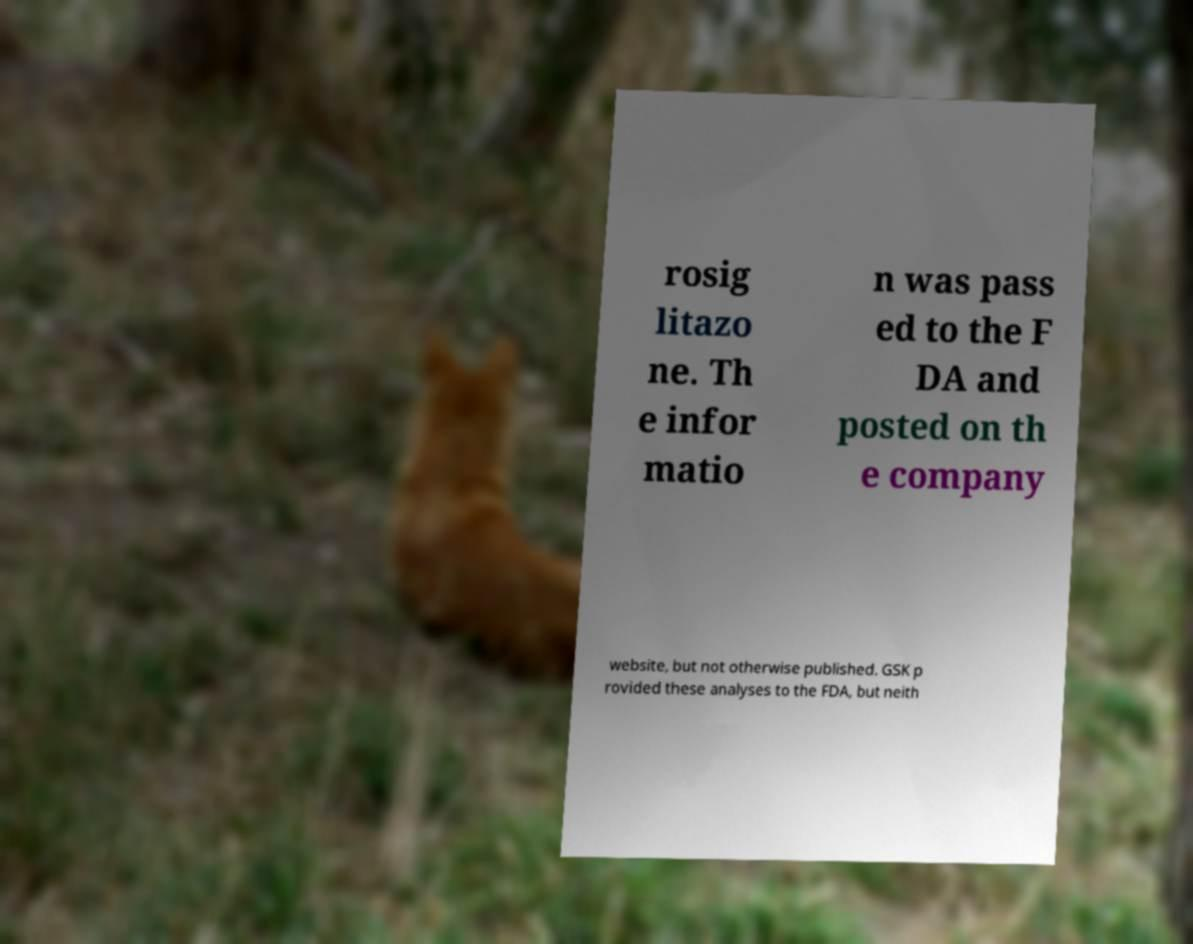Can you read and provide the text displayed in the image?This photo seems to have some interesting text. Can you extract and type it out for me? rosig litazo ne. Th e infor matio n was pass ed to the F DA and posted on th e company website, but not otherwise published. GSK p rovided these analyses to the FDA, but neith 